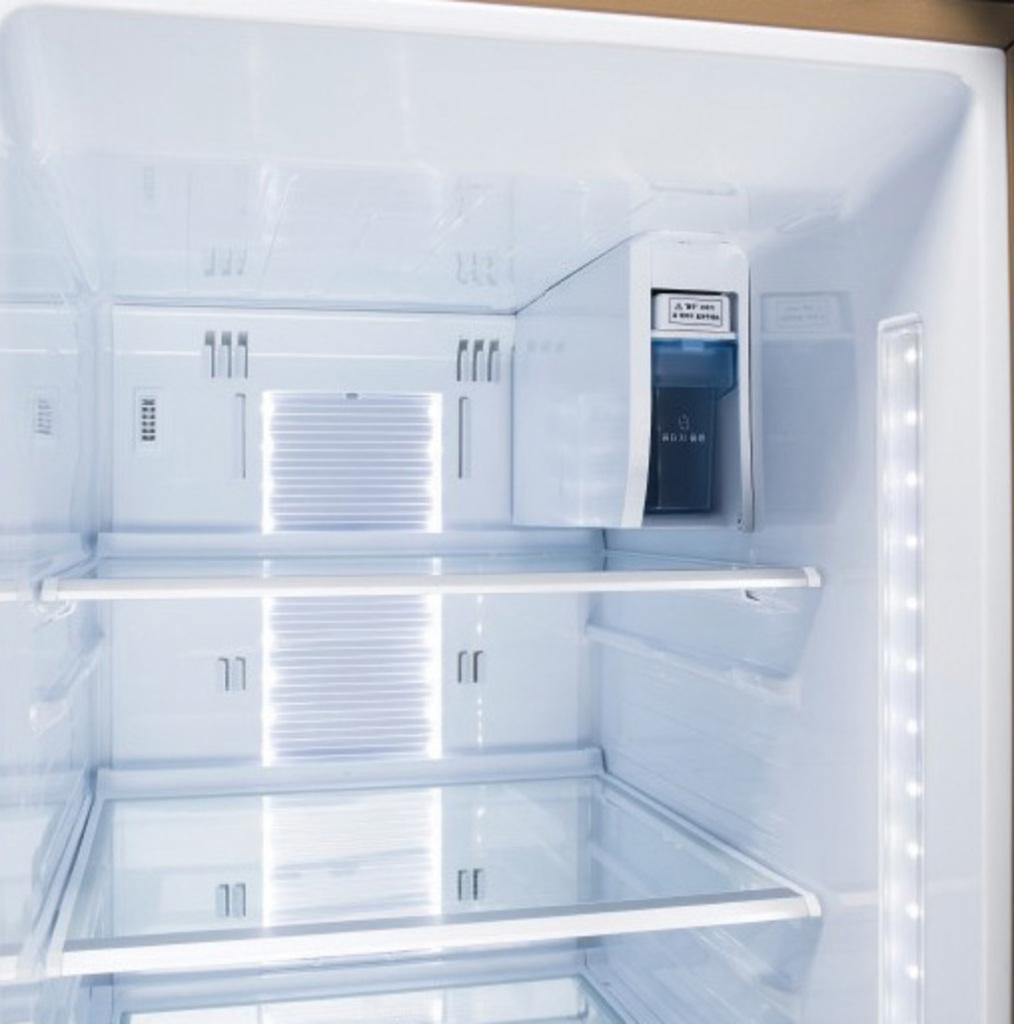What is the main subject of the image? The image shows the inside view of a refrigerator. What color is the refrigerator? The refrigerator is white in color. Are there any distinct sections or compartments visible in the refrigerator? Yes, there are compartments visible in the refrigerator. What type of object can be seen in the refrigerator? There is a black object in the refrigerator. Can you describe the lighting inside the refrigerator? The refrigerator has lights. Who is the creator of the boot seen in the refrigerator? There is no boot present in the image, so it is not possible to determine who created it. 